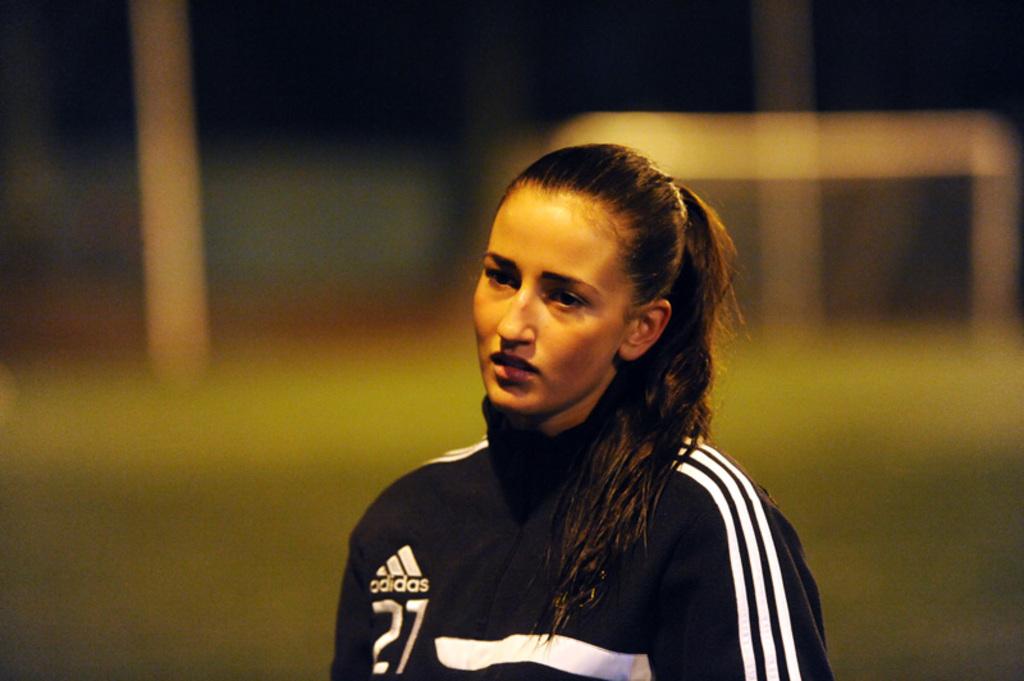The player's number is?
Provide a short and direct response. 27. 